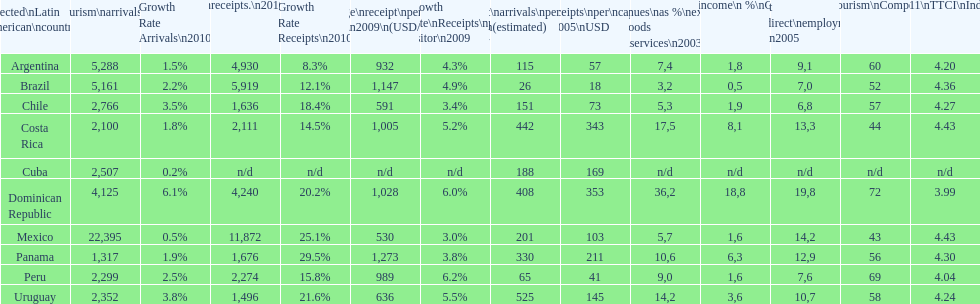During 2003, up to what percentage of gdp did tourism income account for in latin american countries? 18,8. 